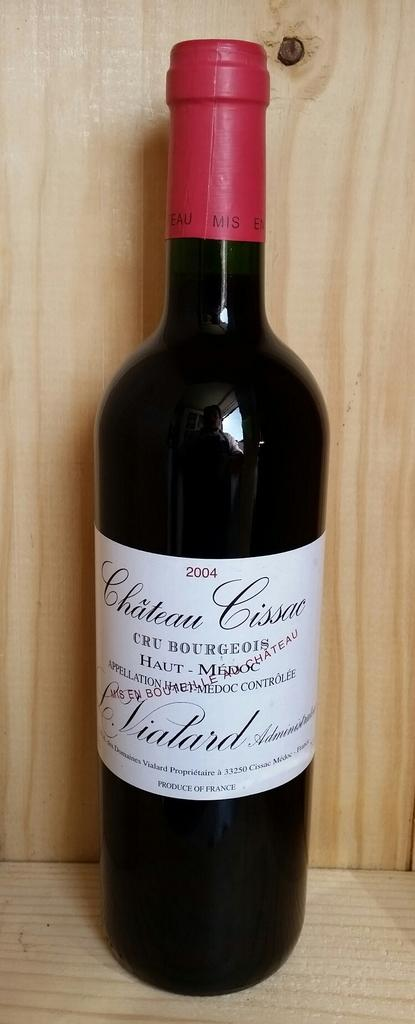<image>
Summarize the visual content of the image. the year 2004 is on a wine bottle 